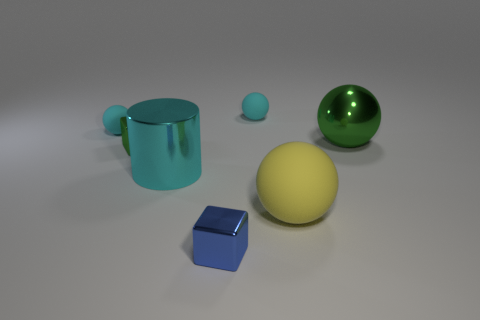Subtract 1 spheres. How many spheres are left? 3 Add 3 green metal objects. How many objects exist? 10 Subtract all cubes. How many objects are left? 5 Subtract 0 blue cylinders. How many objects are left? 7 Subtract all green things. Subtract all green objects. How many objects are left? 3 Add 7 yellow objects. How many yellow objects are left? 8 Add 6 small blue metallic objects. How many small blue metallic objects exist? 7 